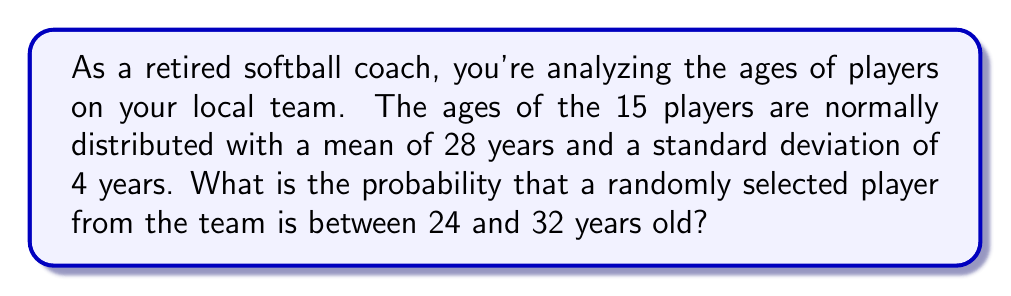Give your solution to this math problem. Let's approach this step-by-step:

1) We're dealing with a normal distribution where:
   $\mu = 28$ (mean age)
   $\sigma = 4$ (standard deviation of ages)

2) We want to find $P(24 \leq X \leq 32)$, where X is the age of a randomly selected player.

3) To use the standard normal distribution, we need to standardize these values:
   For 24 years: $z_1 = \frac{24 - 28}{4} = -1$
   For 32 years: $z_2 = \frac{32 - 28}{4} = 1$

4) Now we're looking for $P(-1 \leq Z \leq 1)$, where Z is the standard normal variable.

5) This probability is equal to the area under the standard normal curve between -1 and 1.

6) Using the standard normal table or a calculator:
   $P(-1 \leq Z \leq 1) = P(Z \leq 1) - P(Z \leq -1)$
                        $= 0.8413 - 0.1587$
                        $= 0.6826$

7) Therefore, the probability that a randomly selected player is between 24 and 32 years old is approximately 0.6826 or 68.26%.
Answer: 0.6826 